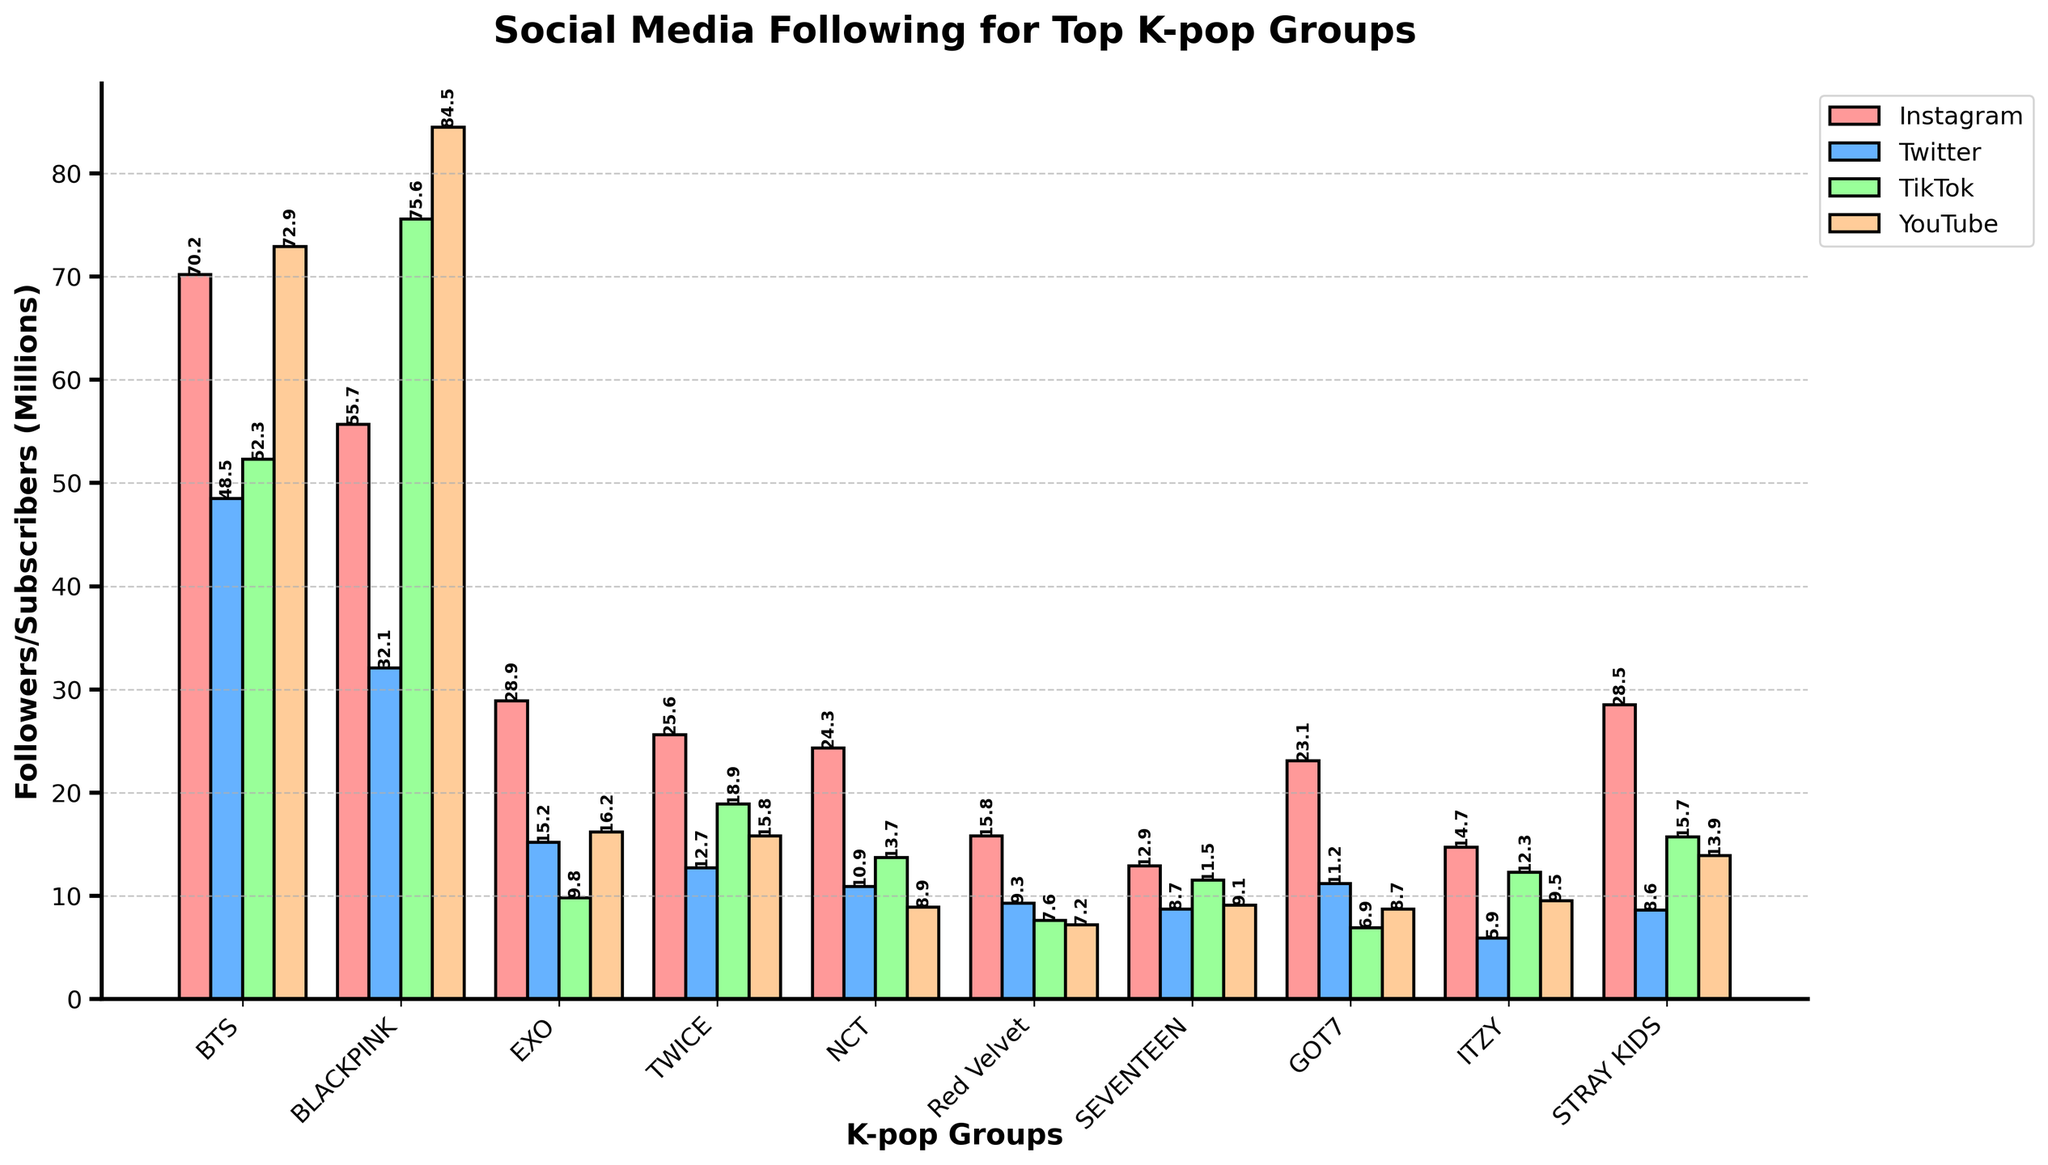Which group has the most followers on Instagram? Look at the bar heights labeled with "Instagram" and find the tallest one. BTS has the tallest bar.
Answer: BTS Which group has the lowest number of YouTube subscribers? Check the bar heights labeled "YouTube" and find the shortest one. Red Velvet has the shortest bar.
Answer: Red Velvet How many more followers does BLACKPINK have on TikTok compared to EXO? Find the heights of the "TikTok" bars for BLACKPINK and EXO, then subtract EXO's value from BLACKPINK's value: 75.6 million - 9.8 million = 65.8 million.
Answer: 65.8 million What is the total number of followers TWICE has across all platforms? Add the heights of TWICE's bars for Instagram, Twitter, TikTok, and YouTube: 25.6 million + 12.7 million + 18.9 million + 15.8 million = 73 million.
Answer: 73 million Which platform has the highest number of followers for SEVENTEEN? Compare the heights of SEVENTEEN's bars across Instagram, Twitter, TikTok, and YouTube. TikTok has the highest bar.
Answer: TikTok Who has more Twitter followers, EXO or NCT? Compare the heights of the "Twitter" bars for EXO and NCT. EXO has a higher bar than NCT.
Answer: EXO What is the average number of YouTube subscribers across all groups? Add the heights of all the "YouTube" bars and divide by the number of groups: (72.9 million + 84.5 million + 16.2 million + 15.8 million + 8.9 million + 7.2 million + 9.1 million + 8.7 million + 9.5 million + 13.9 million) / 10 = 24.28 million.
Answer: 24.28 million Which group has the least difference between their Twitter and Instagram followers? Calculate the difference between Twitter and Instagram followers for each group and find the smallest difference. For GOT7, the difference is 23.1 million - 11.2 million = 11.9 million, which is the smallest.
Answer: GOT7 